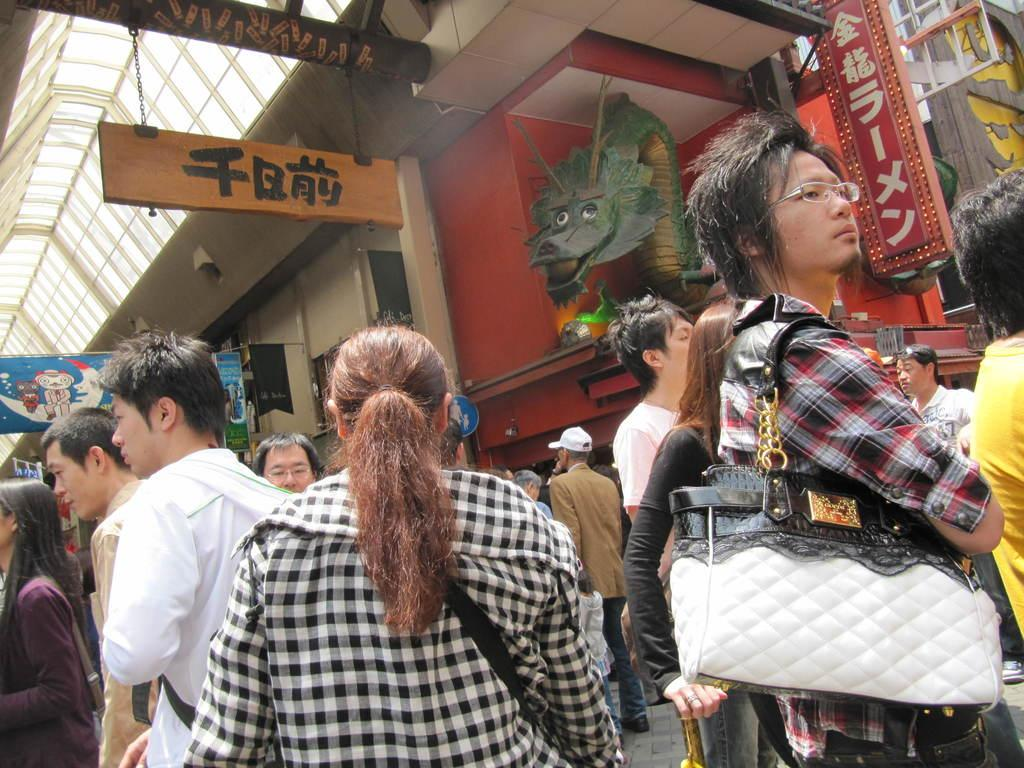Who or what can be seen in the image? There are people in the image. What can be seen in the background of the image? There is a sculpture in the background of the image. What else is visible in the image? There are boards visible in the image. What type of structure is present in the image? There is a building in the image. What type of slope can be seen in the image? There is no slope present in the image. 